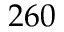Convert formula to latex. <formula><loc_0><loc_0><loc_500><loc_500>2 6 0</formula> 